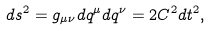Convert formula to latex. <formula><loc_0><loc_0><loc_500><loc_500>d s ^ { 2 } = g _ { \mu \nu } d q ^ { \mu } d q ^ { \nu } = 2 C ^ { 2 } d t ^ { 2 } ,</formula> 